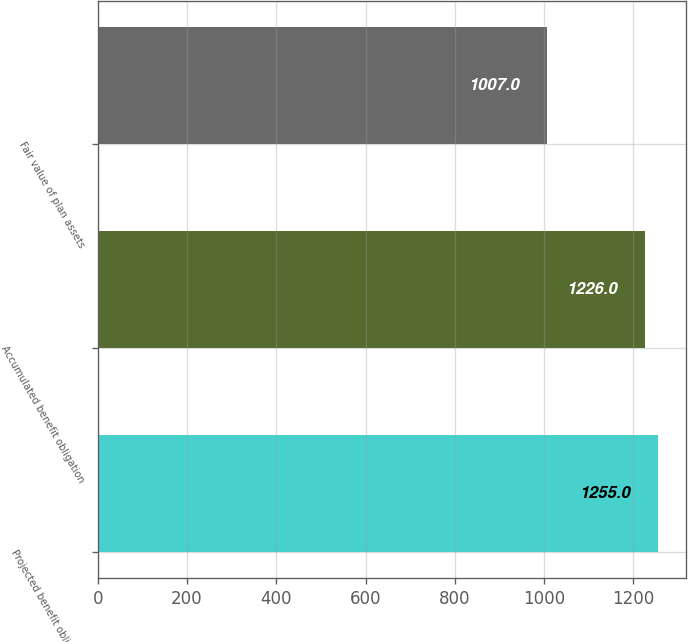Convert chart. <chart><loc_0><loc_0><loc_500><loc_500><bar_chart><fcel>Projected benefit obligation<fcel>Accumulated benefit obligation<fcel>Fair value of plan assets<nl><fcel>1255<fcel>1226<fcel>1007<nl></chart> 